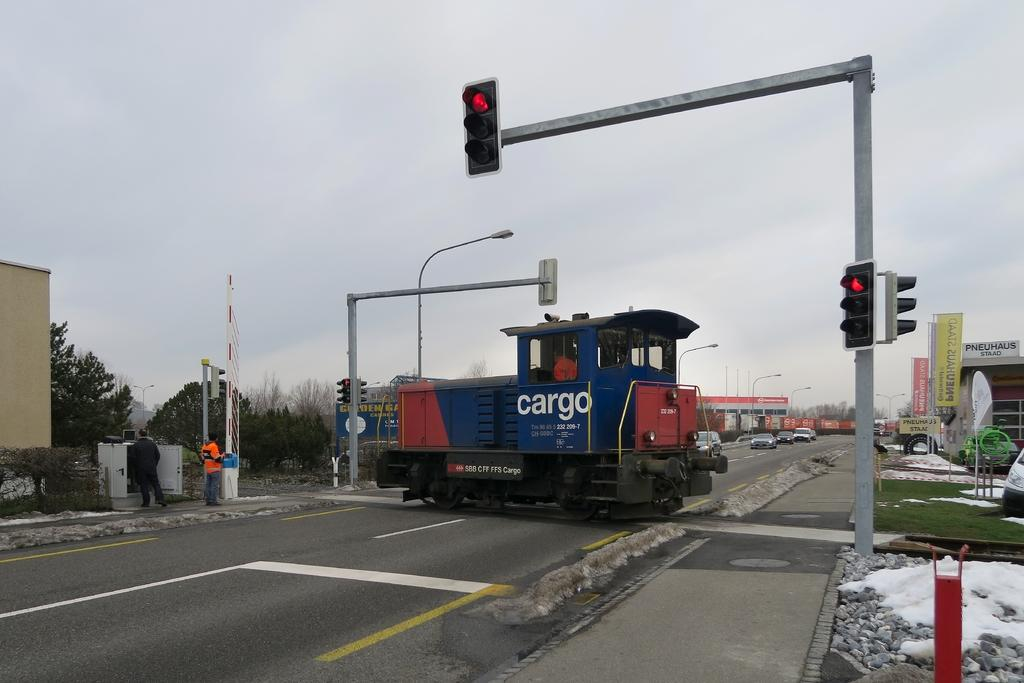<image>
Offer a succinct explanation of the picture presented. The train on the tracks crossing a road is a cargo train. 